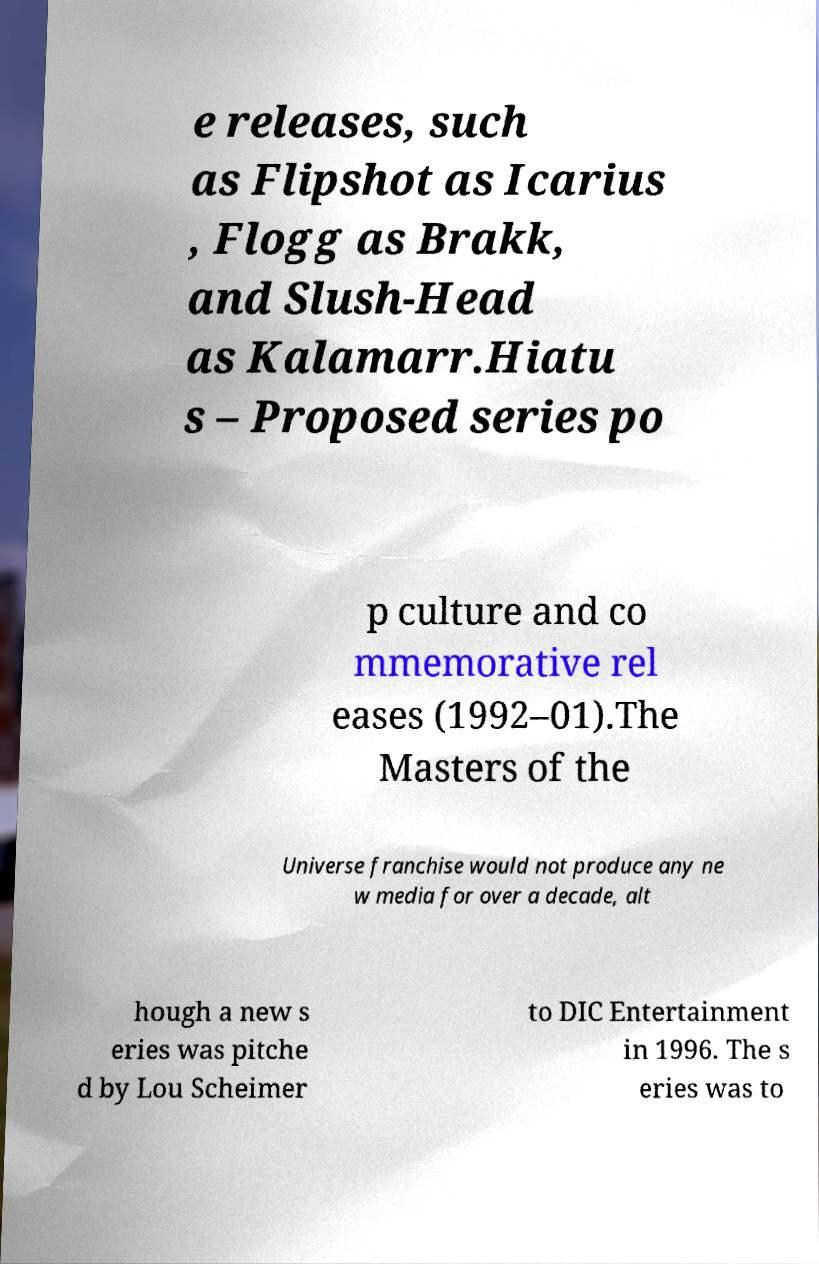Could you extract and type out the text from this image? e releases, such as Flipshot as Icarius , Flogg as Brakk, and Slush-Head as Kalamarr.Hiatu s – Proposed series po p culture and co mmemorative rel eases (1992–01).The Masters of the Universe franchise would not produce any ne w media for over a decade, alt hough a new s eries was pitche d by Lou Scheimer to DIC Entertainment in 1996. The s eries was to 